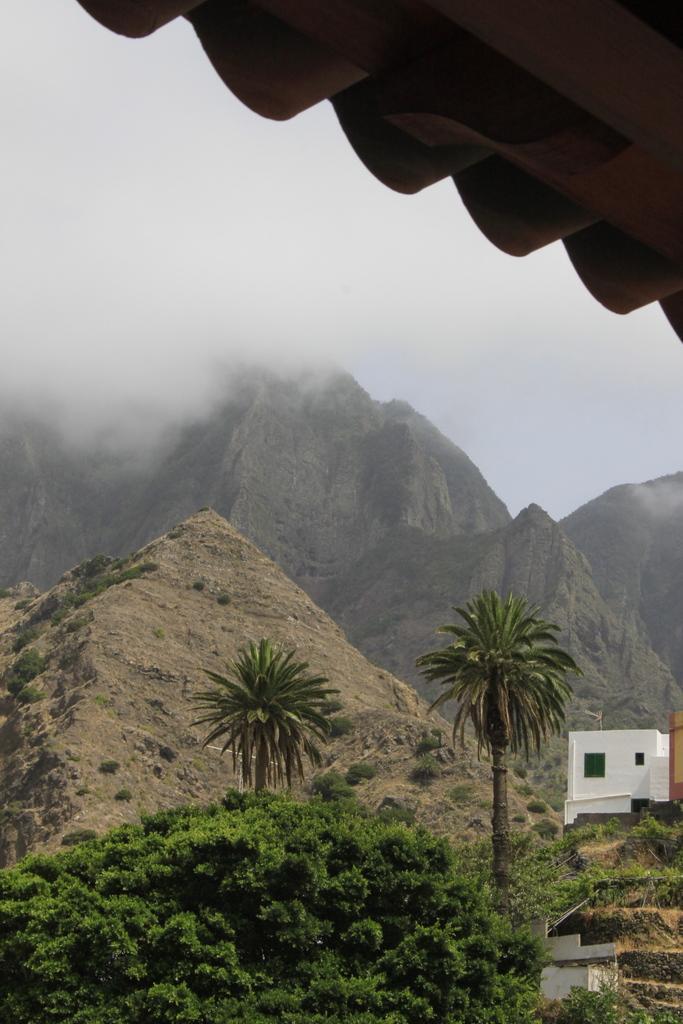How would you summarize this image in a sentence or two? This picture shows few houses and we see trees and hills and we see fog. 